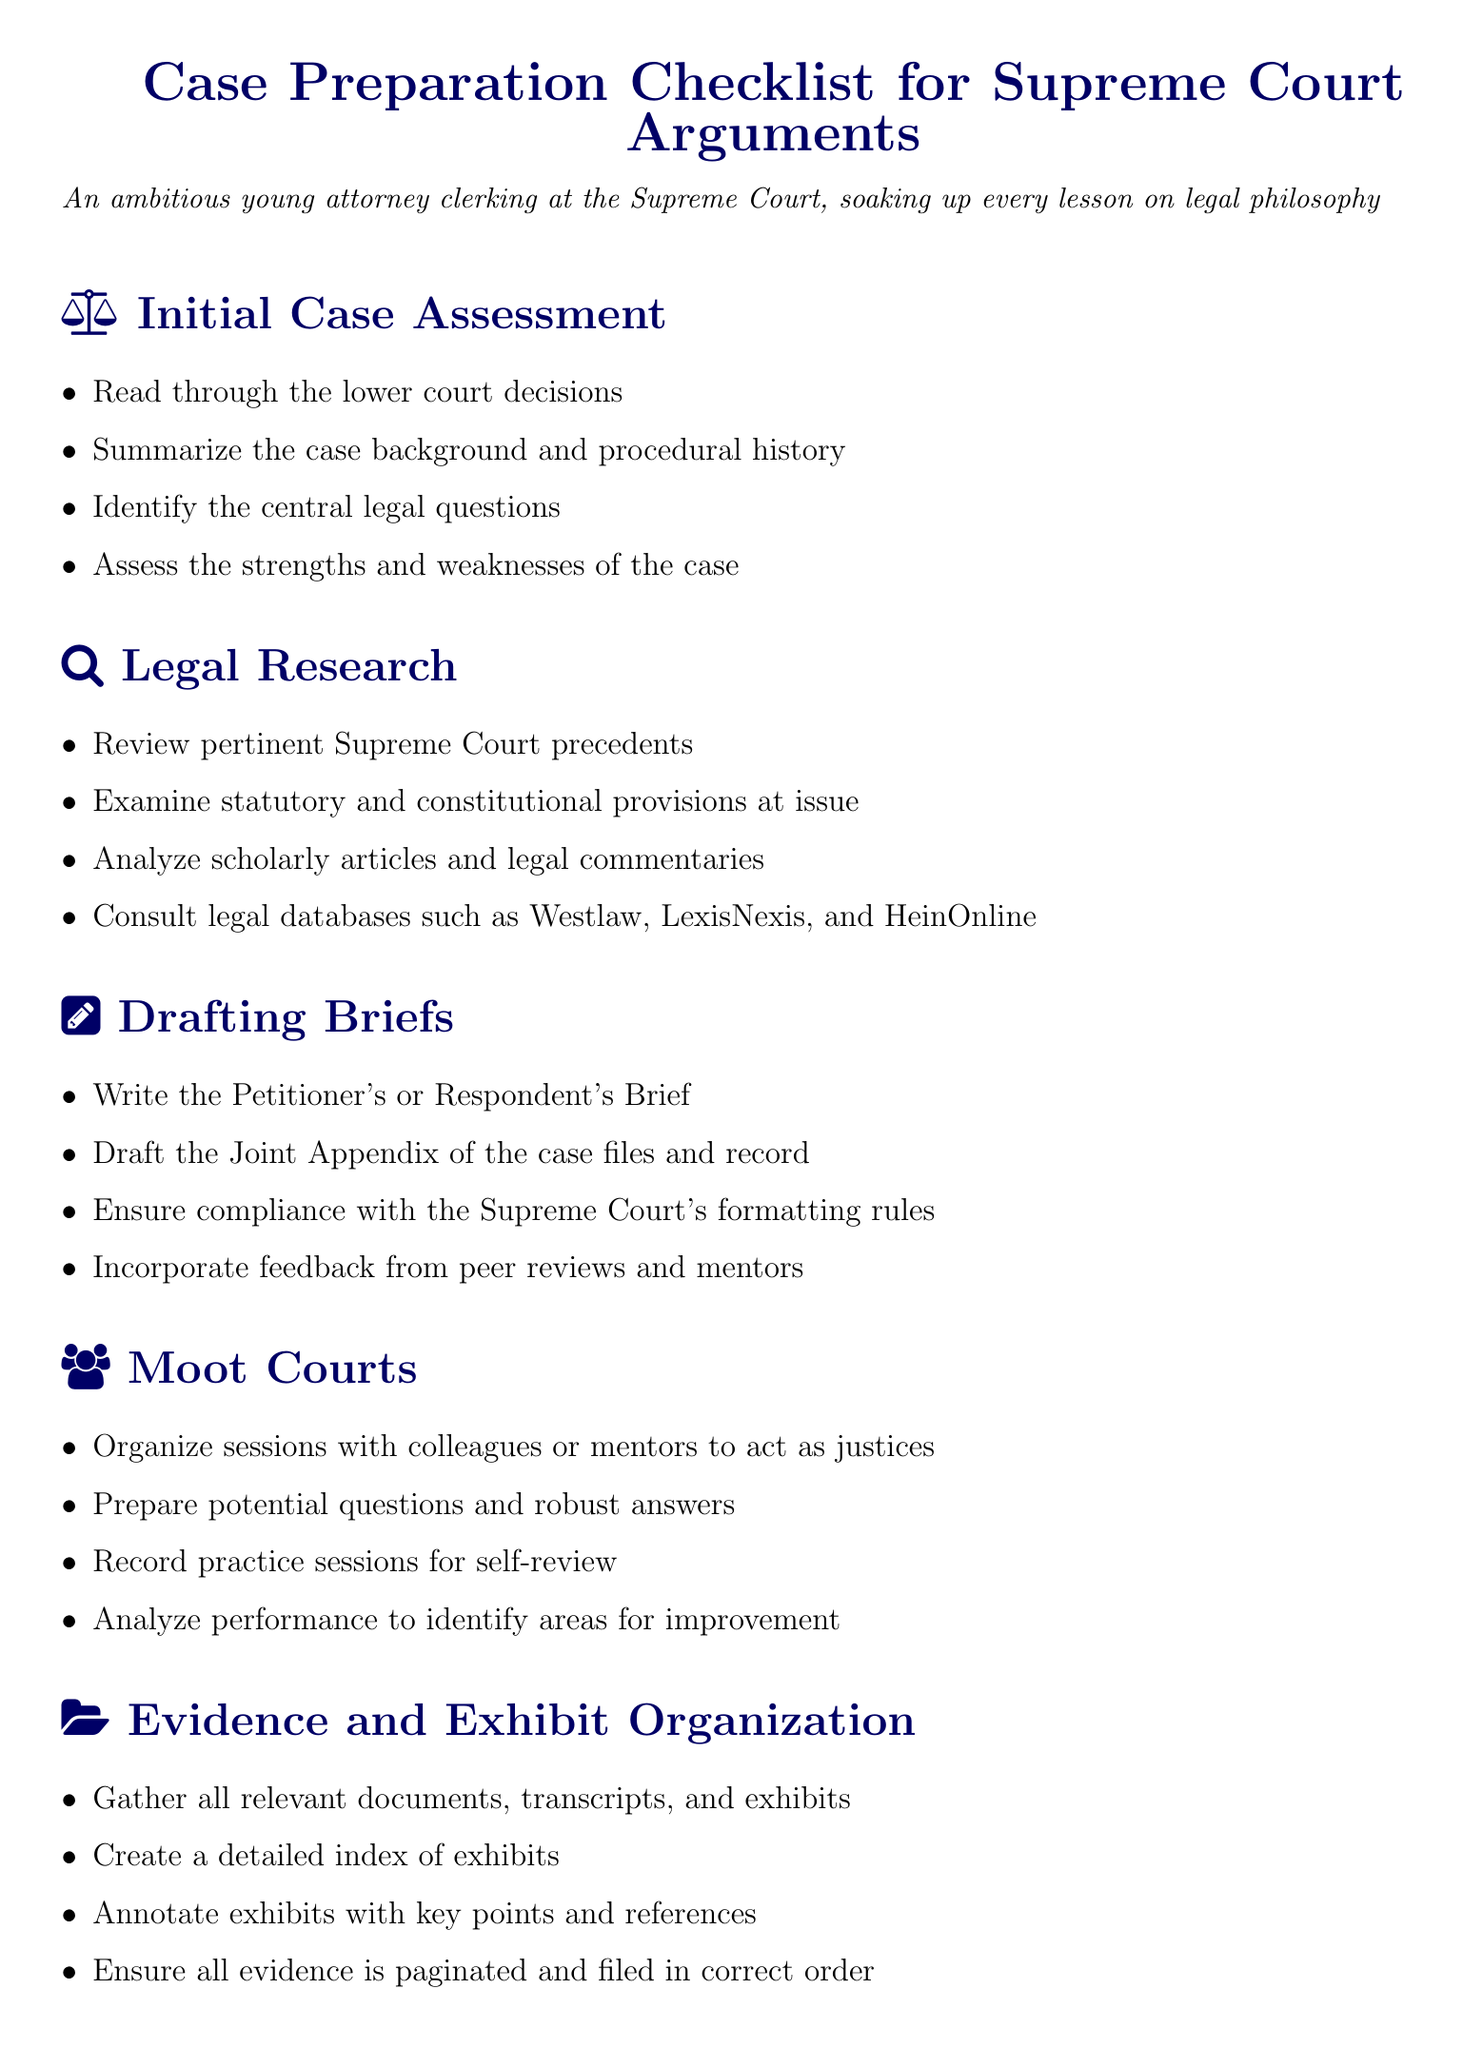What is the total number of sections in the checklist? The checklist consists of different sections, specifically identified in the document, which includes Initial Case Assessment, Legal Research, Drafting Briefs, Moot Courts, Evidence and Exhibit Organization, and Final Preparations. Count of those sections gives the total.
Answer: 6 What is the first step in the Initial Case Assessment? This is outlined as part of the Initial Case Assessment section where the first specified task is to read through the lower court decisions.
Answer: Read through the lower court decisions What type of documents should be reviewed during the Legal Research phase? The document mentions different types of documents that are crucial for research, specifically noting the Supreme Court precedents, statutory and constitutional provisions, scholarly articles, and legal commentaries.
Answer: Supreme Court precedents What do you need to prepare for in the Moot Courts section? The checklist outlines important preparations to be made for the moot court sessions, specifically highlighting the need to prepare potential questions and robust answers.
Answer: Prepare potential questions and robust answers Which final checks are mentioned before the court hearing? The Final Preparations section highlights that a final review of all briefs and appendices is necessary before proceeding.
Answer: Final review of all briefs and appendices What is the purpose of annotating exhibits in the Evidence and Exhibit Organization? This action serves to clarify key points and references that are essential when presenting evidence.
Answer: Clarify key points and references 